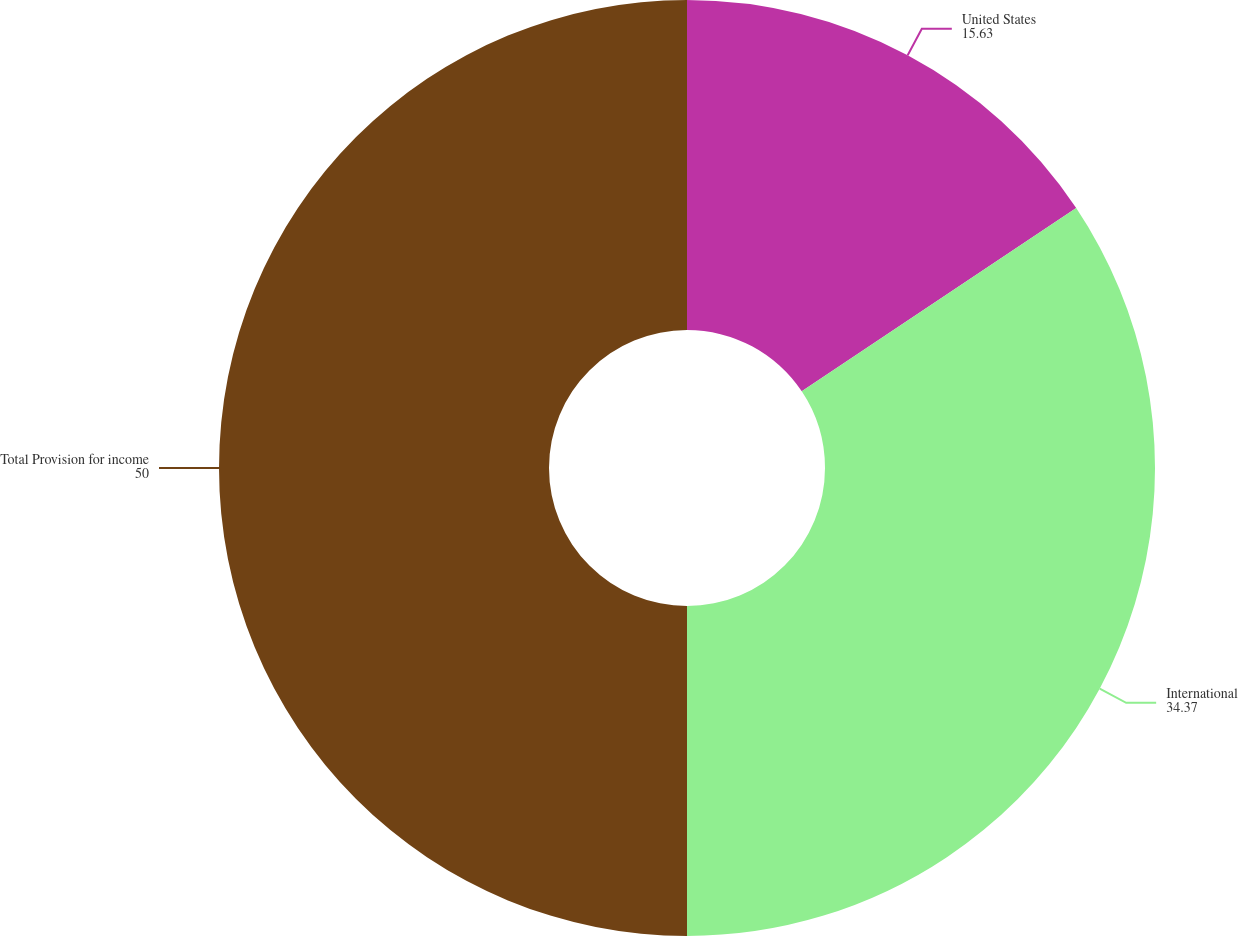Convert chart to OTSL. <chart><loc_0><loc_0><loc_500><loc_500><pie_chart><fcel>United States<fcel>International<fcel>Total Provision for income<nl><fcel>15.63%<fcel>34.37%<fcel>50.0%<nl></chart> 